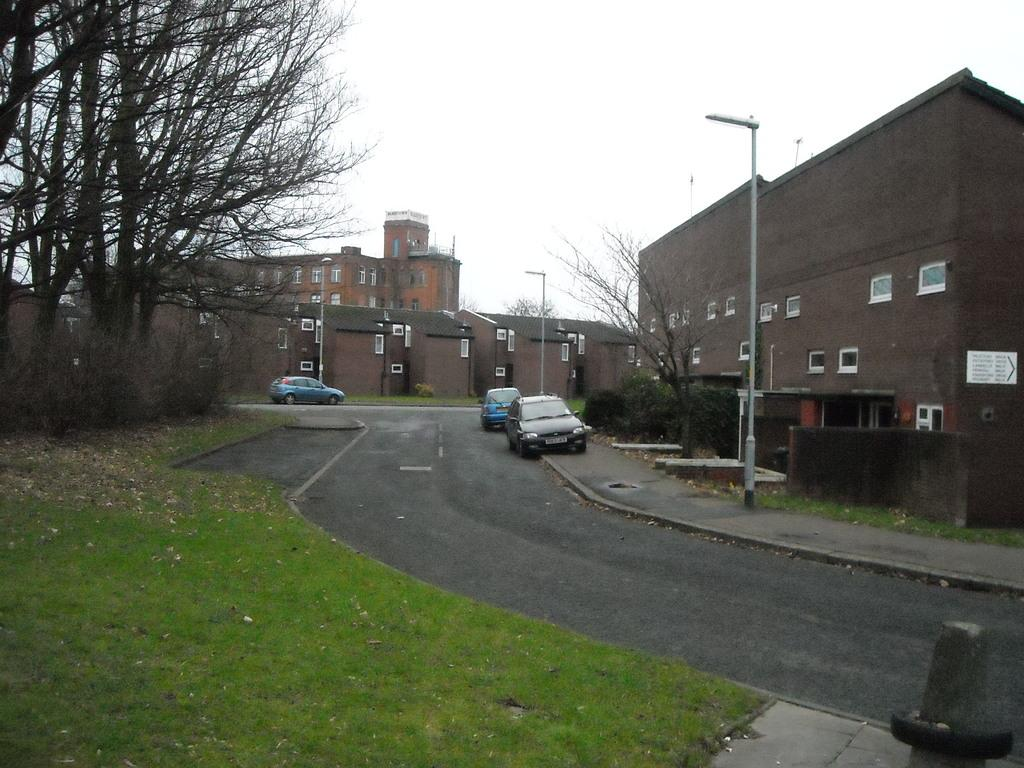What type of structures can be seen in the image? There are buildings in the image. What else can be seen in the image besides buildings? There are poles, trees, bushes, green grass, a road, and 3 cars in the image. How many cars are visible in the image? There are 3 cars in the image. What is the condition of the sky in the background of the image? The sky is visible in the background of the image, and it is clear. Where is the lettuce growing in the image? There is no lettuce present in the image. What type of pipe can be seen connecting the buildings in the image? There are no pipes connecting the buildings in the image. 